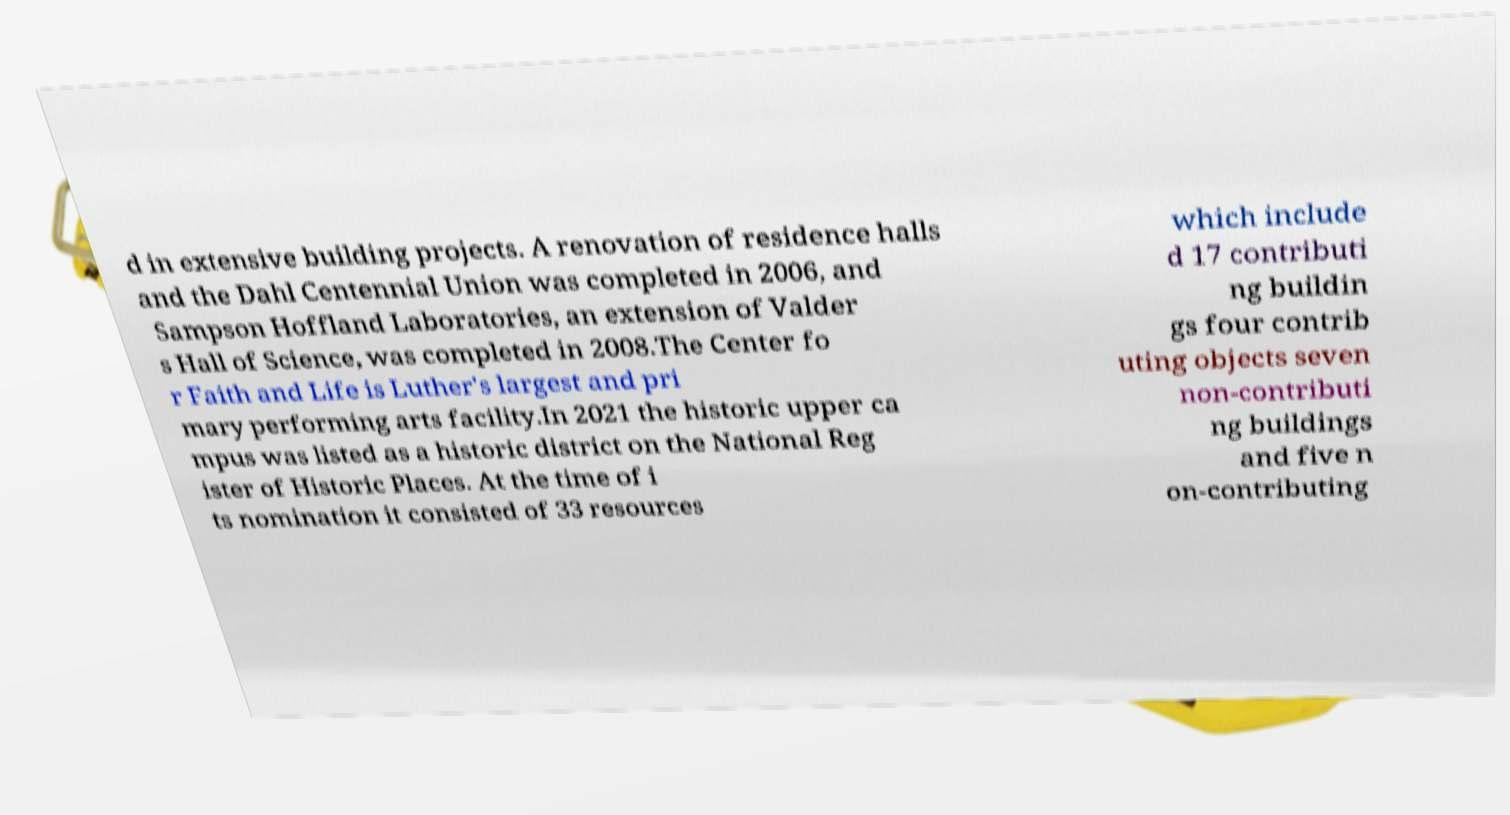Could you extract and type out the text from this image? d in extensive building projects. A renovation of residence halls and the Dahl Centennial Union was completed in 2006, and Sampson Hoffland Laboratories, an extension of Valder s Hall of Science, was completed in 2008.The Center fo r Faith and Life is Luther's largest and pri mary performing arts facility.In 2021 the historic upper ca mpus was listed as a historic district on the National Reg ister of Historic Places. At the time of i ts nomination it consisted of 33 resources which include d 17 contributi ng buildin gs four contrib uting objects seven non-contributi ng buildings and five n on-contributing 